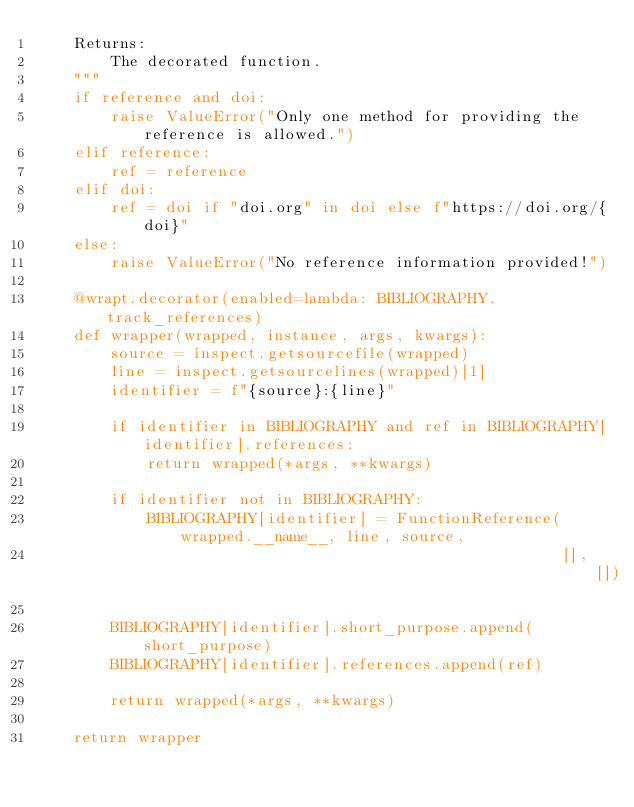<code> <loc_0><loc_0><loc_500><loc_500><_Python_>    Returns:
        The decorated function.
    """
    if reference and doi:
        raise ValueError("Only one method for providing the reference is allowed.")
    elif reference:
        ref = reference
    elif doi:
        ref = doi if "doi.org" in doi else f"https://doi.org/{doi}"
    else:
        raise ValueError("No reference information provided!")

    @wrapt.decorator(enabled=lambda: BIBLIOGRAPHY.track_references)
    def wrapper(wrapped, instance, args, kwargs):
        source = inspect.getsourcefile(wrapped)
        line = inspect.getsourcelines(wrapped)[1]
        identifier = f"{source}:{line}"

        if identifier in BIBLIOGRAPHY and ref in BIBLIOGRAPHY[identifier].references:
            return wrapped(*args, **kwargs)

        if identifier not in BIBLIOGRAPHY:
            BIBLIOGRAPHY[identifier] = FunctionReference(wrapped.__name__, line, source,
                                                         [], [])

        BIBLIOGRAPHY[identifier].short_purpose.append(short_purpose)
        BIBLIOGRAPHY[identifier].references.append(ref)

        return wrapped(*args, **kwargs)

    return wrapper
</code> 